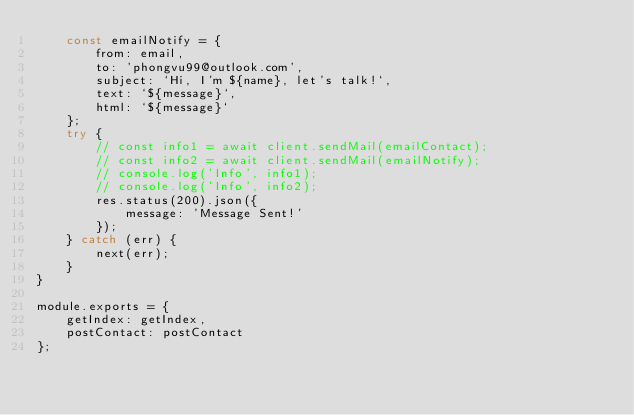<code> <loc_0><loc_0><loc_500><loc_500><_JavaScript_>    const emailNotify = {
        from: email,
        to: 'phongvu99@outlook.com',
        subject: `Hi, I'm ${name}, let's talk!`,
        text: `${message}`,
        html: `${message}`
    };
    try {
        // const info1 = await client.sendMail(emailContact);
        // const info2 = await client.sendMail(emailNotify);
        // console.log('Info', info1);
        // console.log('Info', info2);
        res.status(200).json({
            message: 'Message Sent!'
        });
    } catch (err) {
        next(err);
    }
}

module.exports = {
    getIndex: getIndex,
    postContact: postContact
};</code> 